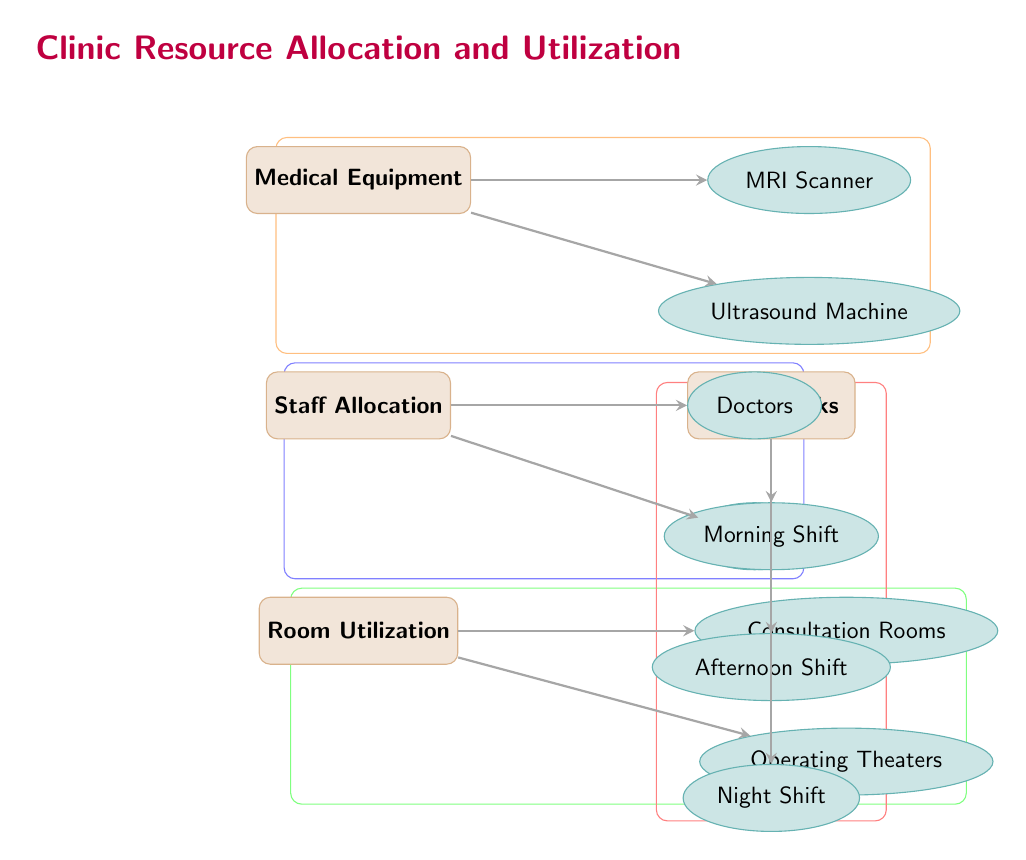What are the two medical equipment types listed? The diagram shows two subcategories under the "Medical Equipment" category: "MRI Scanner" and "Ultrasound Machine".
Answer: MRI Scanner, Ultrasound Machine How many staff allocation types are represented? The diagram contains two subcategories under the "Staff Allocation" category: "Doctors" and "Nurses", which totals to two.
Answer: 2 Which room type is associated with operating procedures? The subcategory "Operating Theaters" is a type of room that is specifically associated with performing surgeries or operations.
Answer: Operating Theaters How many time blocks are indicated in the diagram? There are three time blocks listed under the "Time Blocks" category: "Morning Shift", "Afternoon Shift", and "Night Shift", so the total is three.
Answer: 3 What is the relationship between Staff Allocation and Doctors? "Doctors" is a subcategory that falls under the "Staff Allocation" category, indicating that doctors are part of the staff allocation in the clinic.
Answer: Staff Allocation includes Doctors What color represents the Medical Equipment category in the diagram? The category "Medical Equipment" is represented by a brown color with a light brown fill in the diagram.
Answer: Brown Which room type is utilized for patient consultations? "Consultation Rooms" is the subcategory designated for rooms used for patient consultations.
Answer: Consultation Rooms How many subcategories are there under the Room Utilization category? There are two subcategories under Room Utilization: "Consultation Rooms" and "Operating Theaters", making it a total of two.
Answer: 2 What is the defining characteristic of the Gantt chart represented? The Gantt chart in the context of this diagram would visually represent the allocation and utilization of resources in a time-wise manner for the specified categories, but it is not explicitly shown here.
Answer: Time-wise resource allocation 